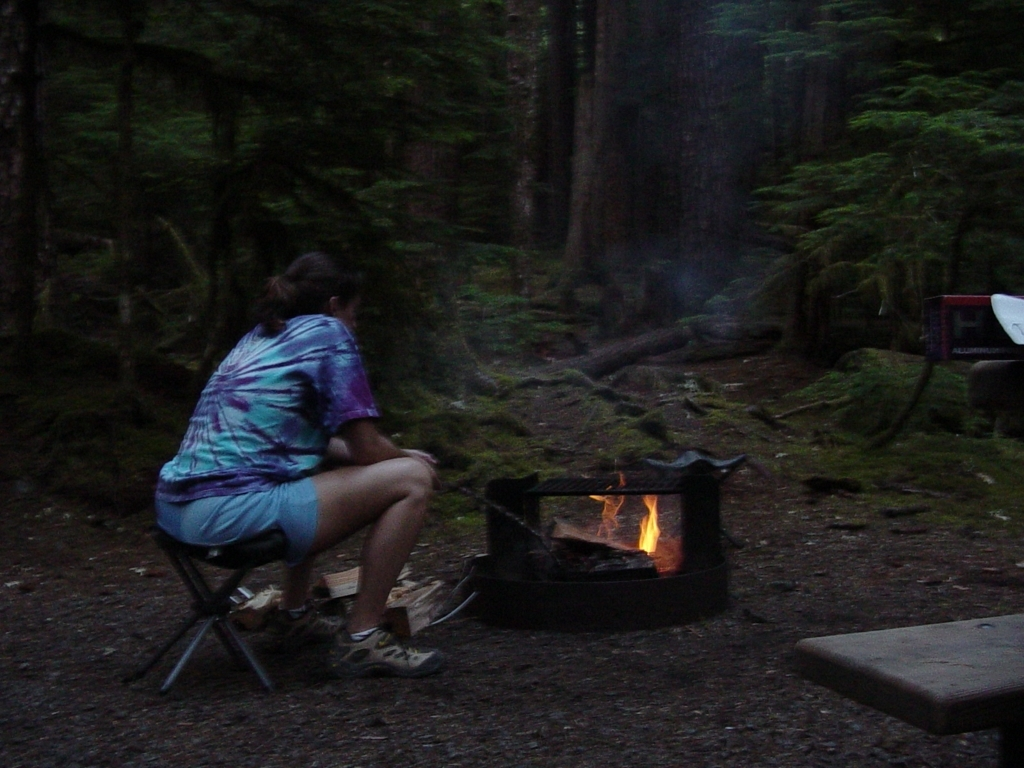What is the overall clarity of the image like?
A. Not high
B. High
C. Excellent The overall clarity of the image is not high, predominantly due to the low lighting conditions and slight blurriness, resulting in a lack of sharpness and fine detail which affects the visibility of the finer features of the scene, such as the textures of the trees and the facial expressions of the person. 